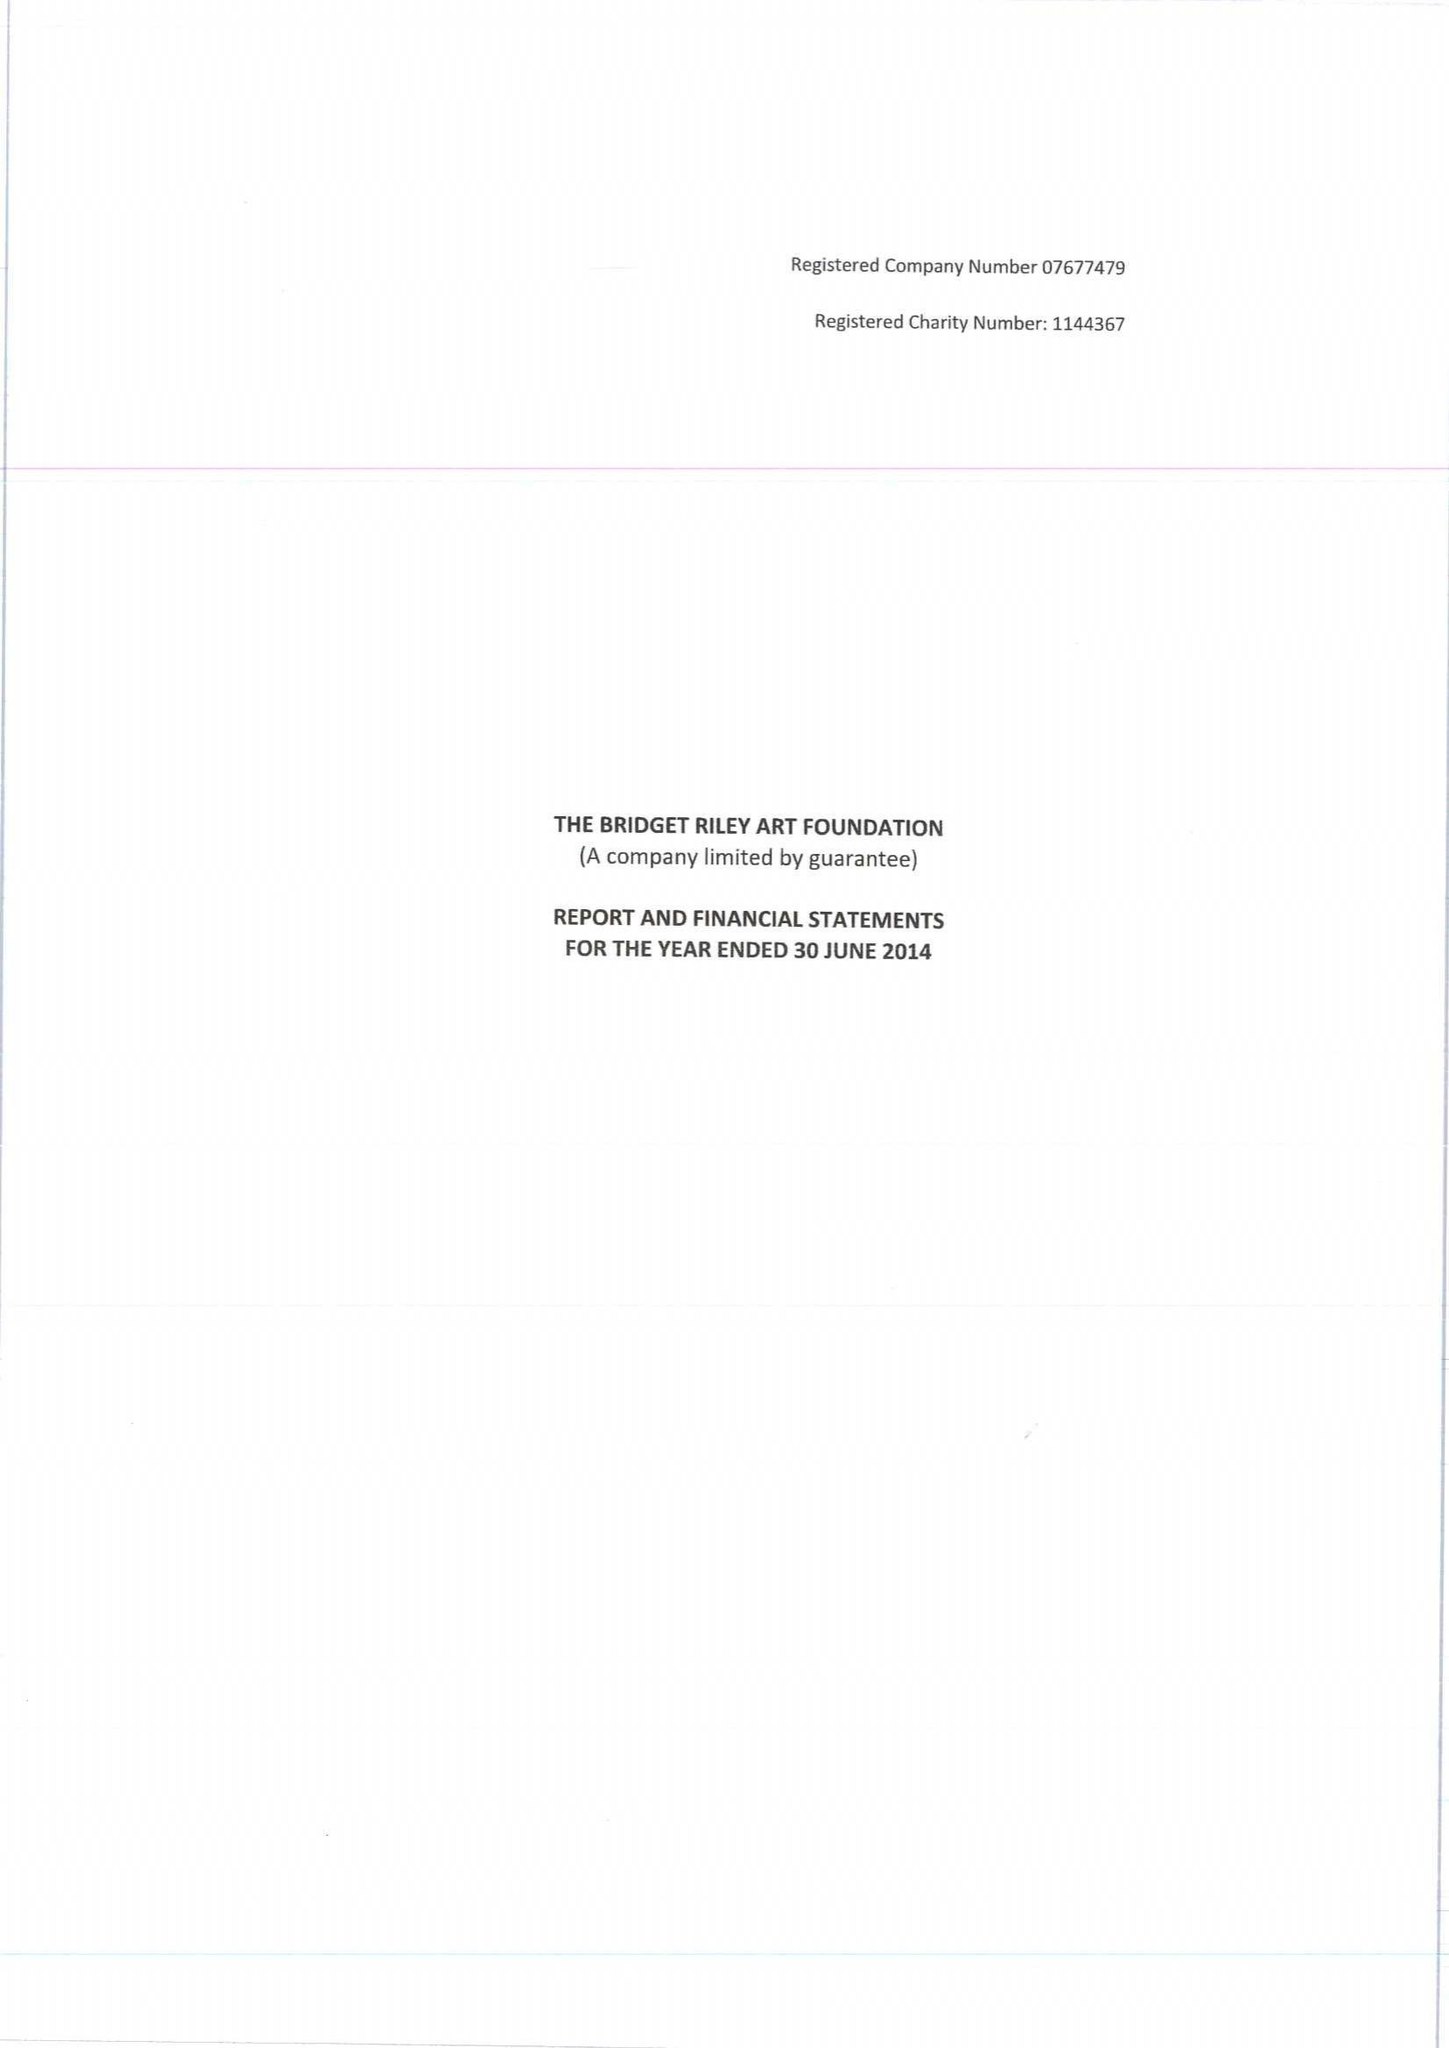What is the value for the report_date?
Answer the question using a single word or phrase. 2014-06-30 